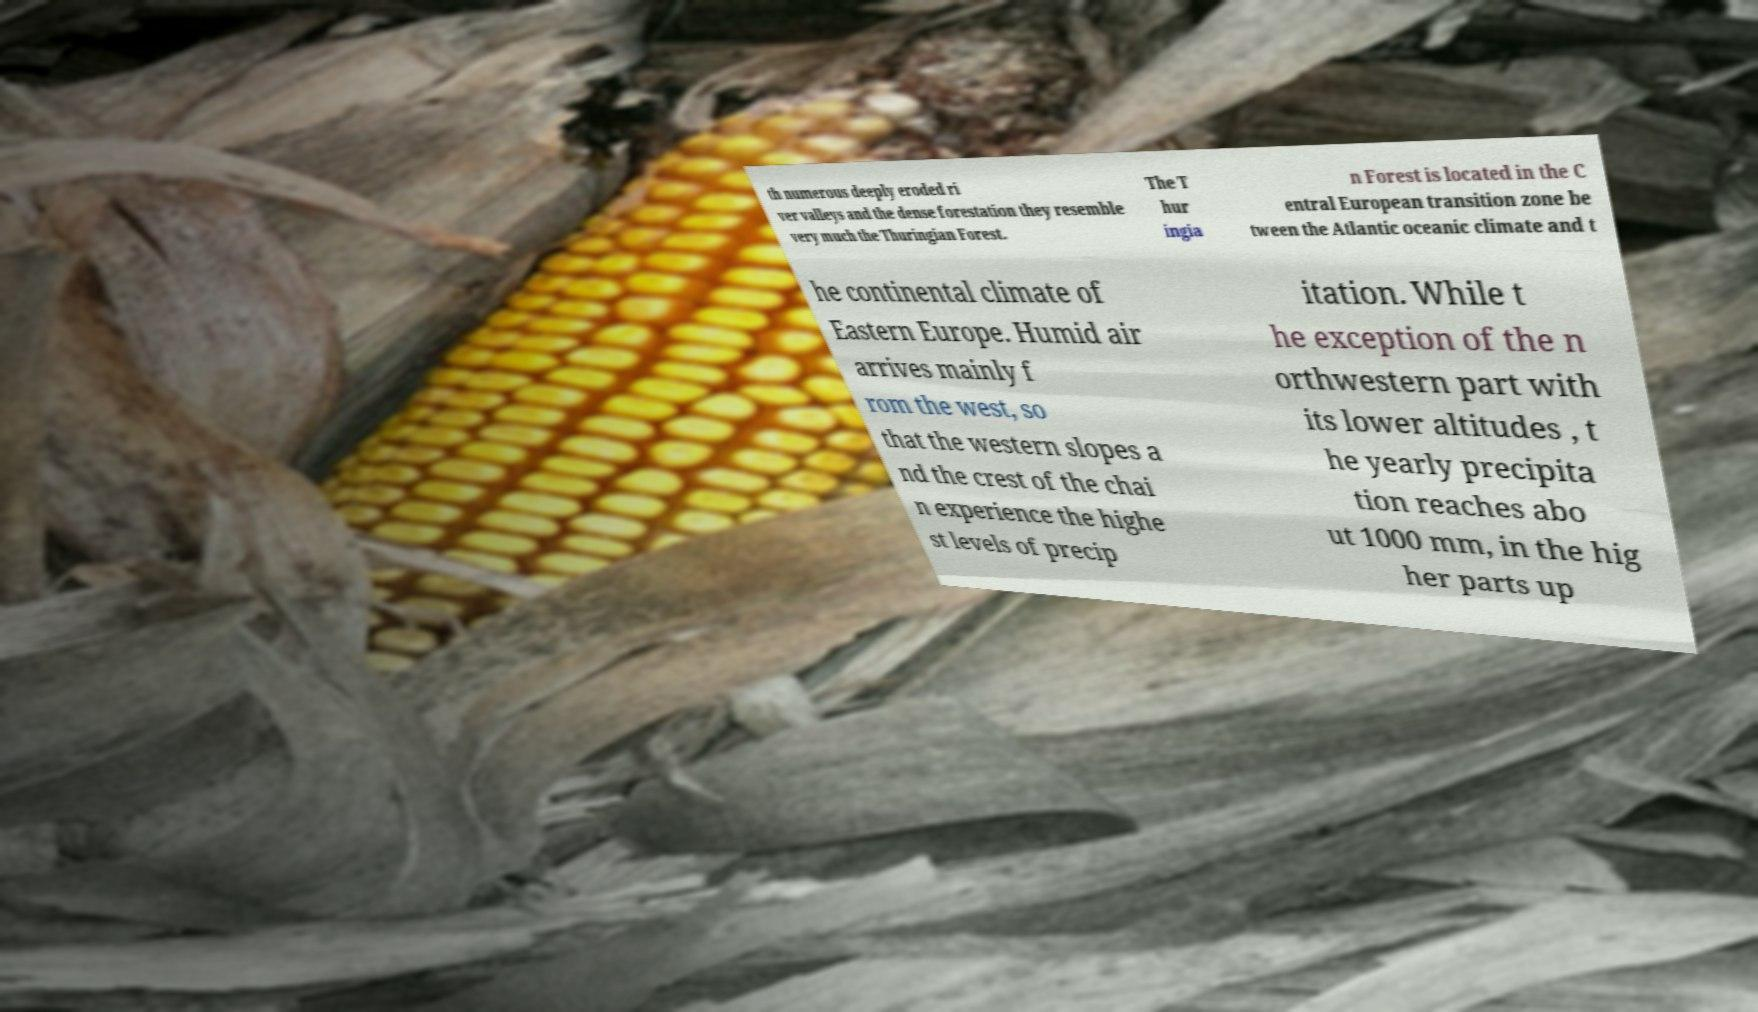Can you accurately transcribe the text from the provided image for me? th numerous deeply eroded ri ver valleys and the dense forestation they resemble very much the Thuringian Forest. The T hur ingia n Forest is located in the C entral European transition zone be tween the Atlantic oceanic climate and t he continental climate of Eastern Europe. Humid air arrives mainly f rom the west, so that the western slopes a nd the crest of the chai n experience the highe st levels of precip itation. While t he exception of the n orthwestern part with its lower altitudes , t he yearly precipita tion reaches abo ut 1000 mm, in the hig her parts up 